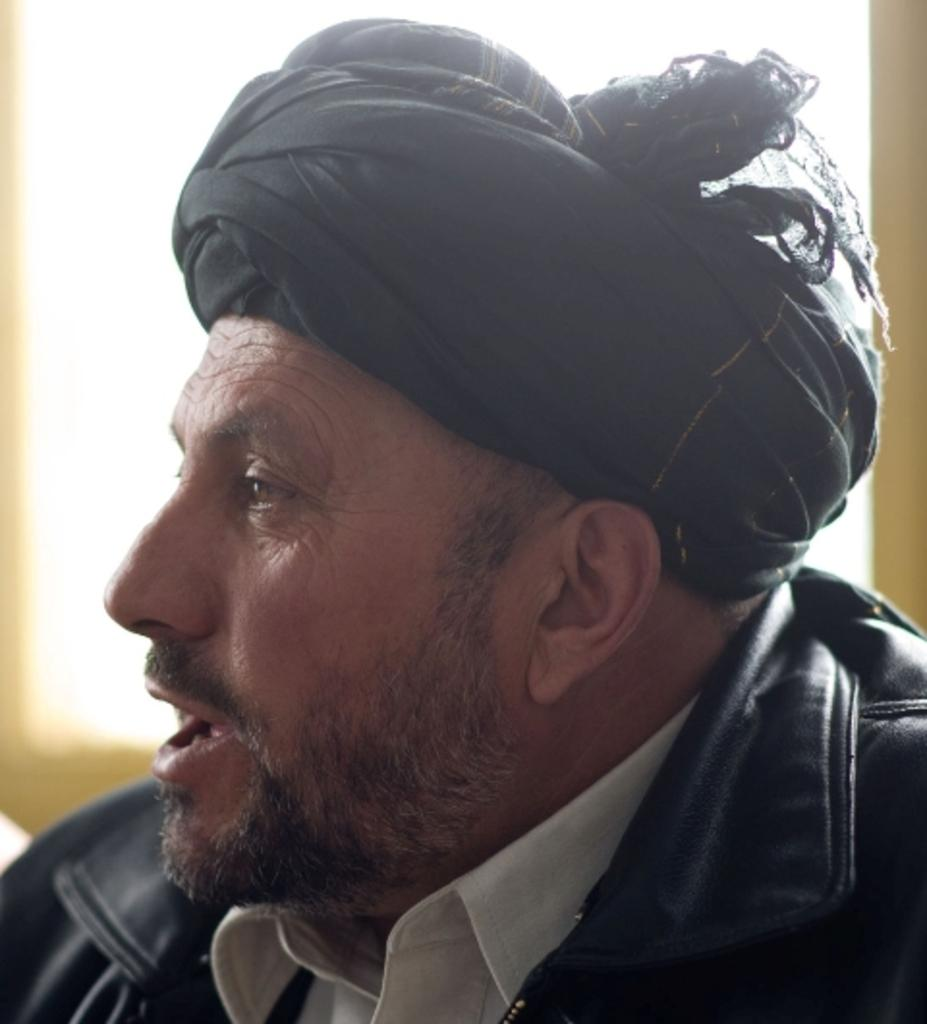What is the main subject of the image? There is a man in the image. How many sisters does the man have in the image? There is no information about the man's sisters in the image, as only the presence of a man is mentioned. 